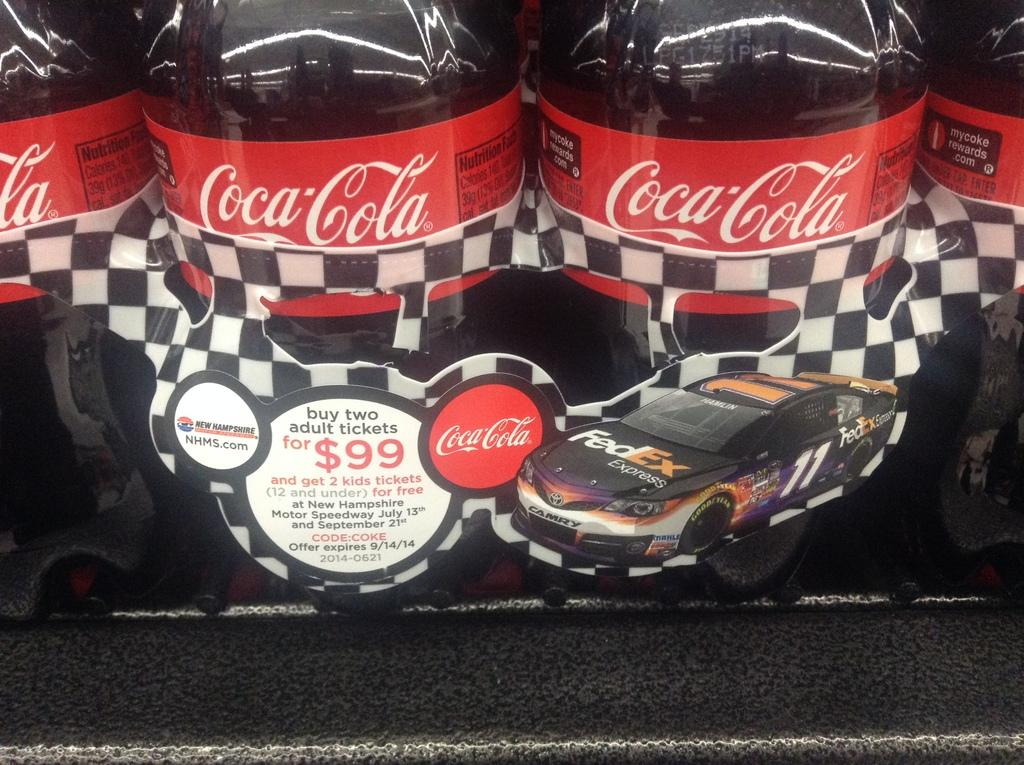What type of beverage bottles are present in the image? There are coca cola bottles in the image. What information is displayed on the bottles? The coca cola bottles have labels on them. What type of winter clothing is visible on the bottles in the image? There is no winter clothing present on the bottles in the image; they are simply coca cola bottles with labels. 